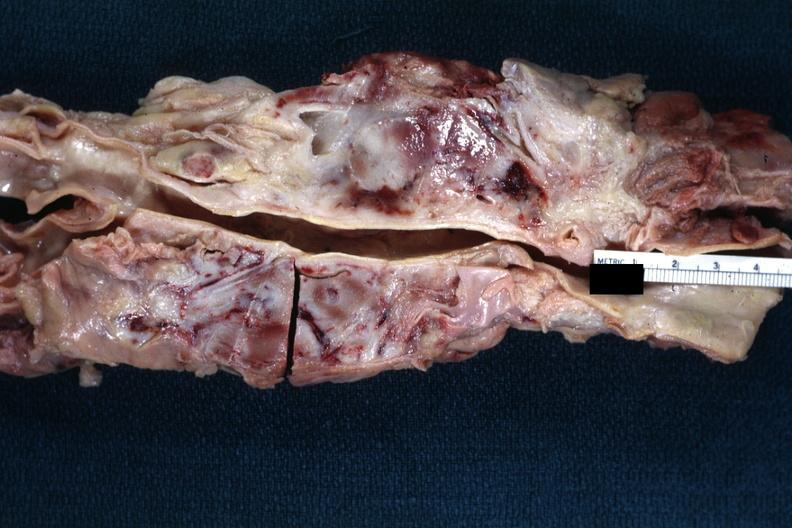s lymph node present?
Answer the question using a single word or phrase. Yes 